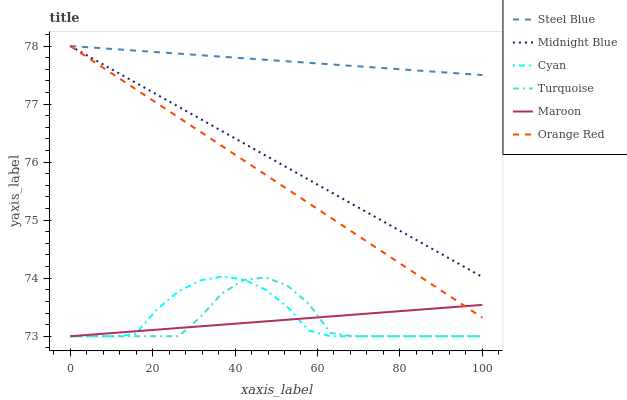Does Turquoise have the minimum area under the curve?
Answer yes or no. Yes. Does Steel Blue have the maximum area under the curve?
Answer yes or no. Yes. Does Midnight Blue have the minimum area under the curve?
Answer yes or no. No. Does Midnight Blue have the maximum area under the curve?
Answer yes or no. No. Is Steel Blue the smoothest?
Answer yes or no. Yes. Is Turquoise the roughest?
Answer yes or no. Yes. Is Midnight Blue the smoothest?
Answer yes or no. No. Is Midnight Blue the roughest?
Answer yes or no. No. Does Turquoise have the lowest value?
Answer yes or no. Yes. Does Midnight Blue have the lowest value?
Answer yes or no. No. Does Orange Red have the highest value?
Answer yes or no. Yes. Does Maroon have the highest value?
Answer yes or no. No. Is Turquoise less than Steel Blue?
Answer yes or no. Yes. Is Orange Red greater than Cyan?
Answer yes or no. Yes. Does Steel Blue intersect Orange Red?
Answer yes or no. Yes. Is Steel Blue less than Orange Red?
Answer yes or no. No. Is Steel Blue greater than Orange Red?
Answer yes or no. No. Does Turquoise intersect Steel Blue?
Answer yes or no. No. 